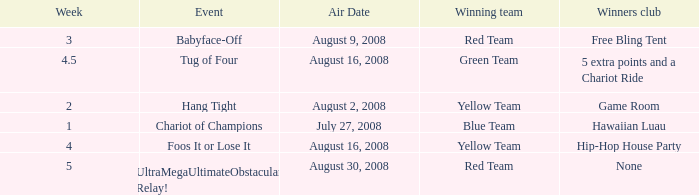Which Winners club has an Event of hang tight? Game Room. 